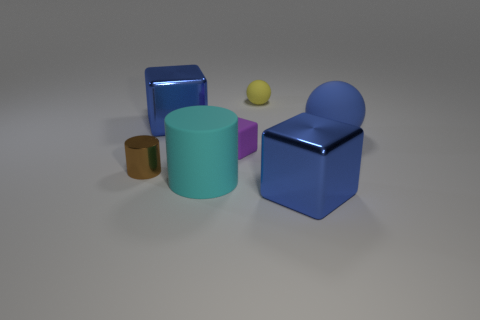Subtract all green spheres. How many blue cubes are left? 2 Add 2 large green metallic blocks. How many objects exist? 9 Subtract all balls. How many objects are left? 5 Add 5 purple rubber cubes. How many purple rubber cubes exist? 6 Subtract 0 cyan cubes. How many objects are left? 7 Subtract all blocks. Subtract all blue rubber things. How many objects are left? 3 Add 3 small yellow spheres. How many small yellow spheres are left? 4 